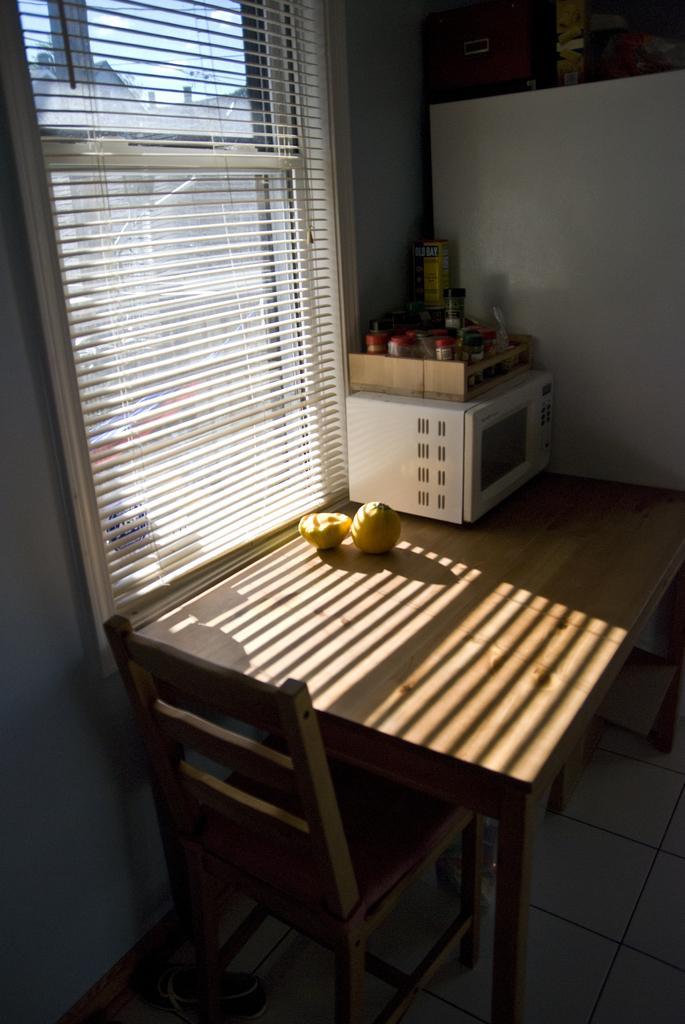Describe this image in one or two sentences. In this image I can see few fruits, an oven on the table and I can also see the chair. In the background I can see the window blind and the sky is in white color. 